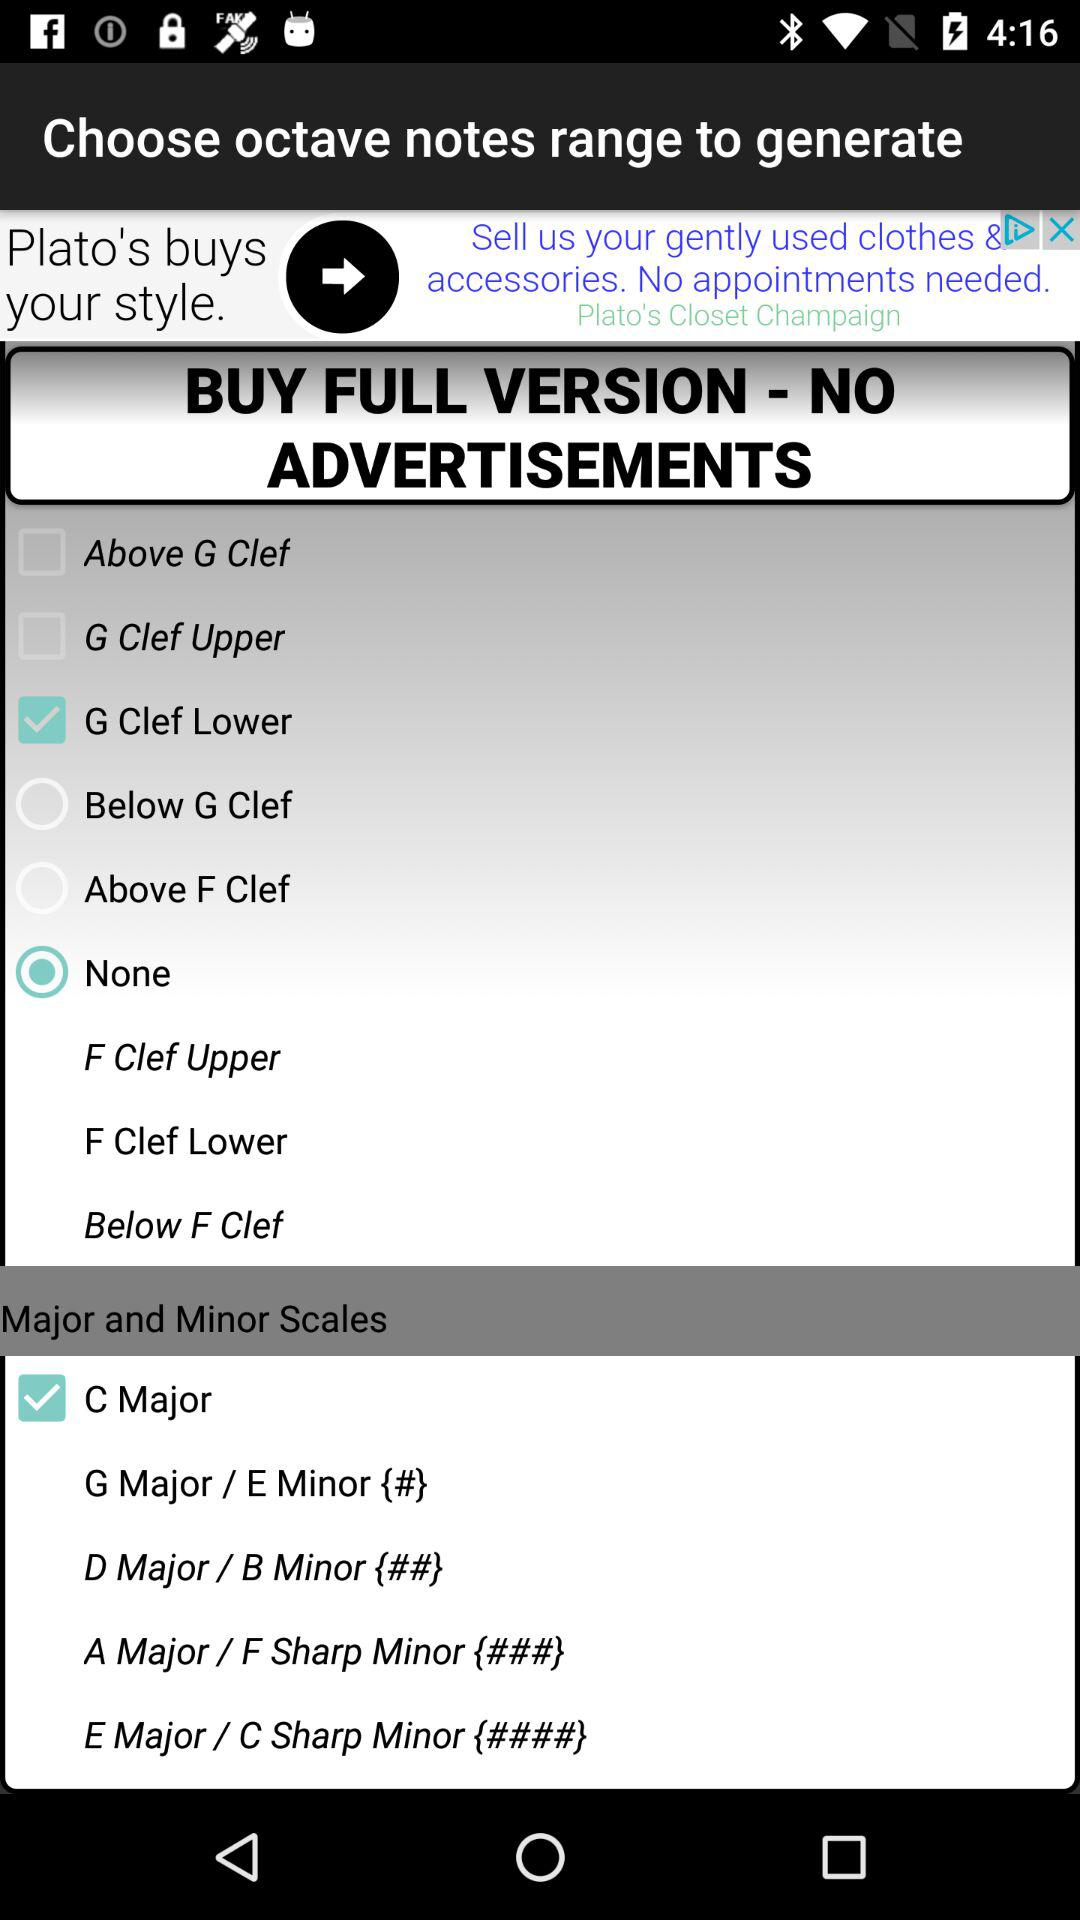What's the status of "C Major"? The status of "C Major" is "on". 